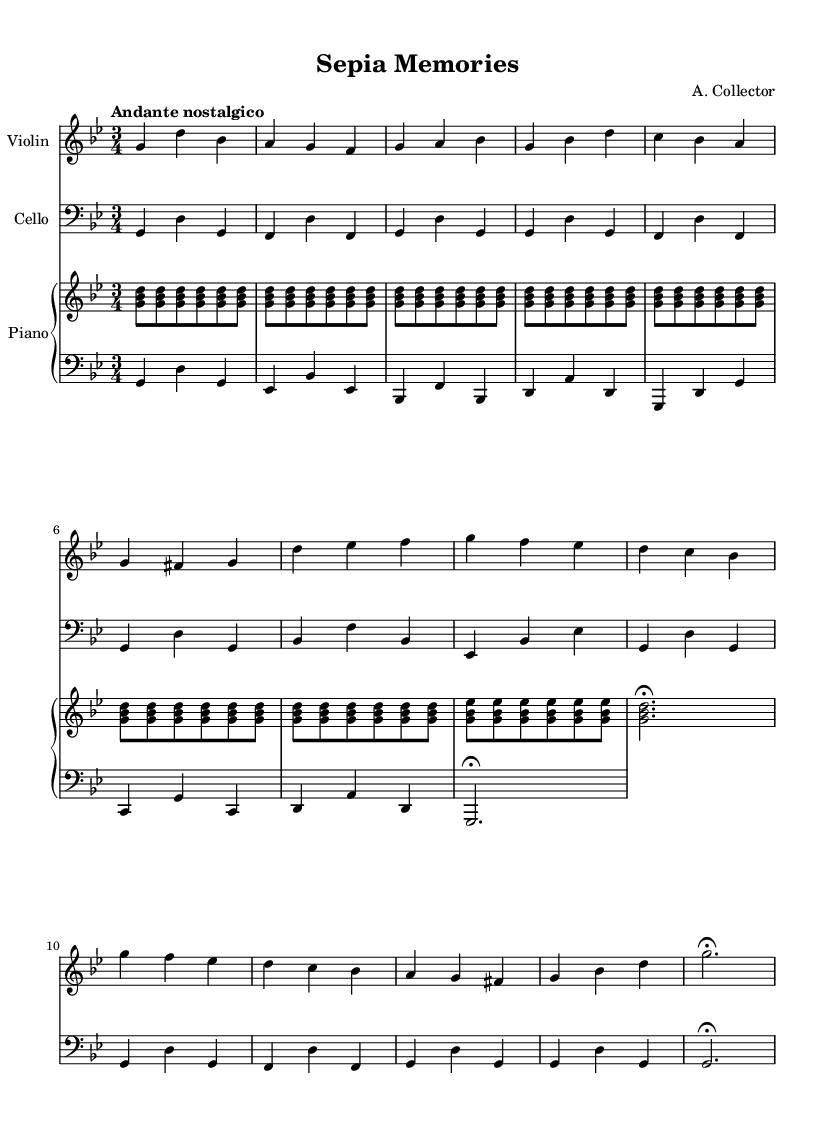What is the key signature of this piece? The key signature indicated in the sheet music shows two flats, which corresponds to G minor.
Answer: G minor What is the time signature? The time signature specified in the music is three beats per measure, denoted by "3/4".
Answer: 3/4 What is the tempo marking for the piece? The tempo marking given indicates a speed that is slow and reflective, denoted as "Andante nostalgico".
Answer: Andante nostalgico How many measures are in the piece? Counting the distinct measures from the music notation, there are a total of sixteen measures.
Answer: 16 What instruments are featured in this composition? The sheet music lists three instruments: Violin, Cello, and Piano.
Answer: Violin, Cello, Piano Which theme is repeated in the piece? The sheet music indicates that "Theme A" is repeated, as shown in the structure where it appears multiple times within the composition.
Answer: Theme A 